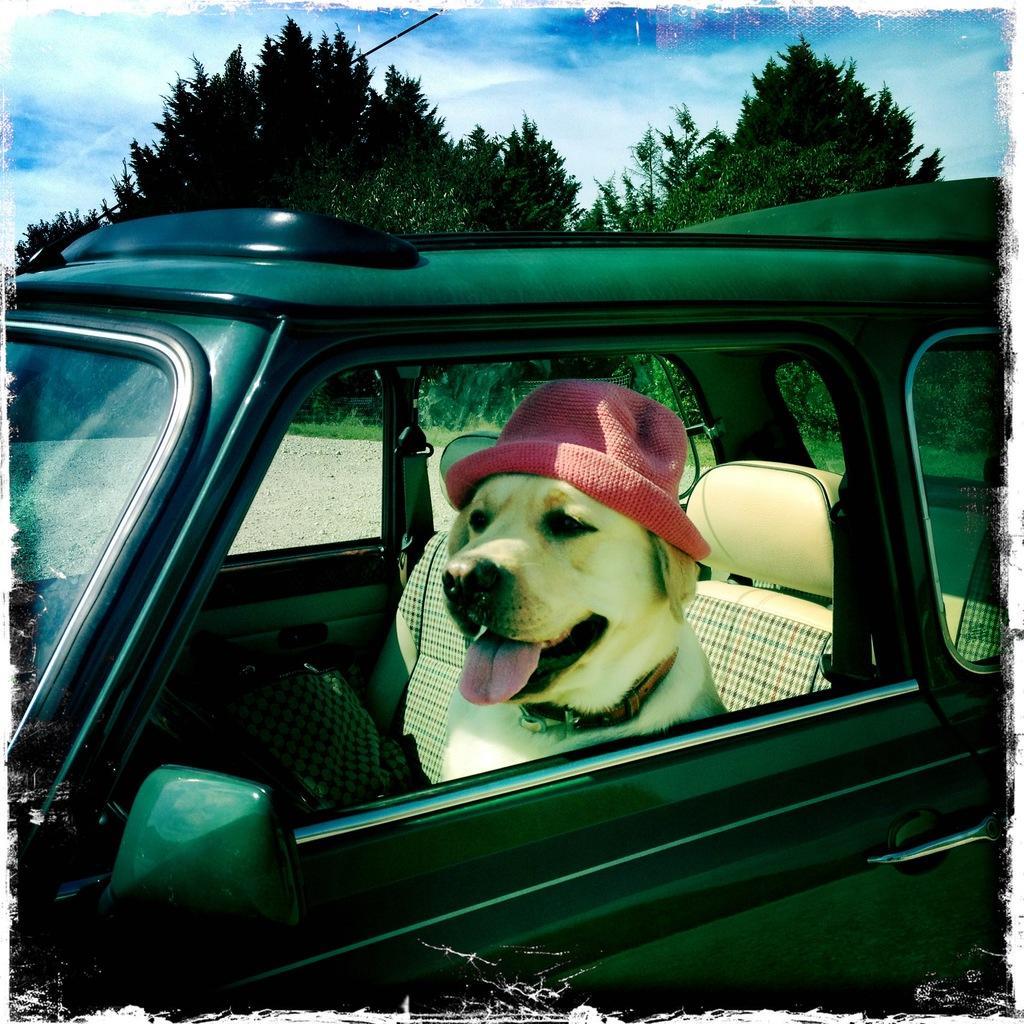In one or two sentences, can you explain what this image depicts? There is a dog wearing a pink hat is sitting in a black car. 